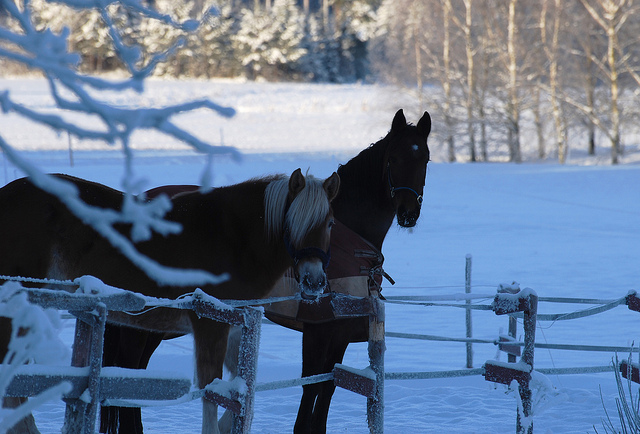How many horses can you see? There are two horses in the image, both positioned close to each other behind a frost-covered fence. One horse appears to be a dark breed with a black coat, while the other is light-colored with a distinctive blond mane. 